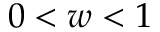<formula> <loc_0><loc_0><loc_500><loc_500>0 < w < 1</formula> 